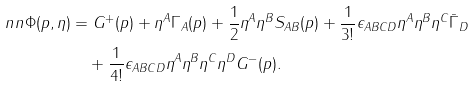Convert formula to latex. <formula><loc_0><loc_0><loc_500><loc_500>\ n n \Phi ( p , \eta ) & = G ^ { + } ( p ) + \eta ^ { A } \Gamma _ { A } ( p ) + \frac { 1 } { 2 } \eta ^ { A } \eta ^ { B } S _ { A B } ( p ) + \frac { 1 } { 3 ! } \epsilon _ { A B C D } \eta ^ { A } \eta ^ { B } \eta ^ { C } \bar { \Gamma } _ { D } \\ & \quad + \frac { 1 } { 4 ! } \epsilon _ { A B C D } \eta ^ { A } \eta ^ { B } \eta ^ { C } \eta ^ { D } G ^ { - } ( p ) .</formula> 